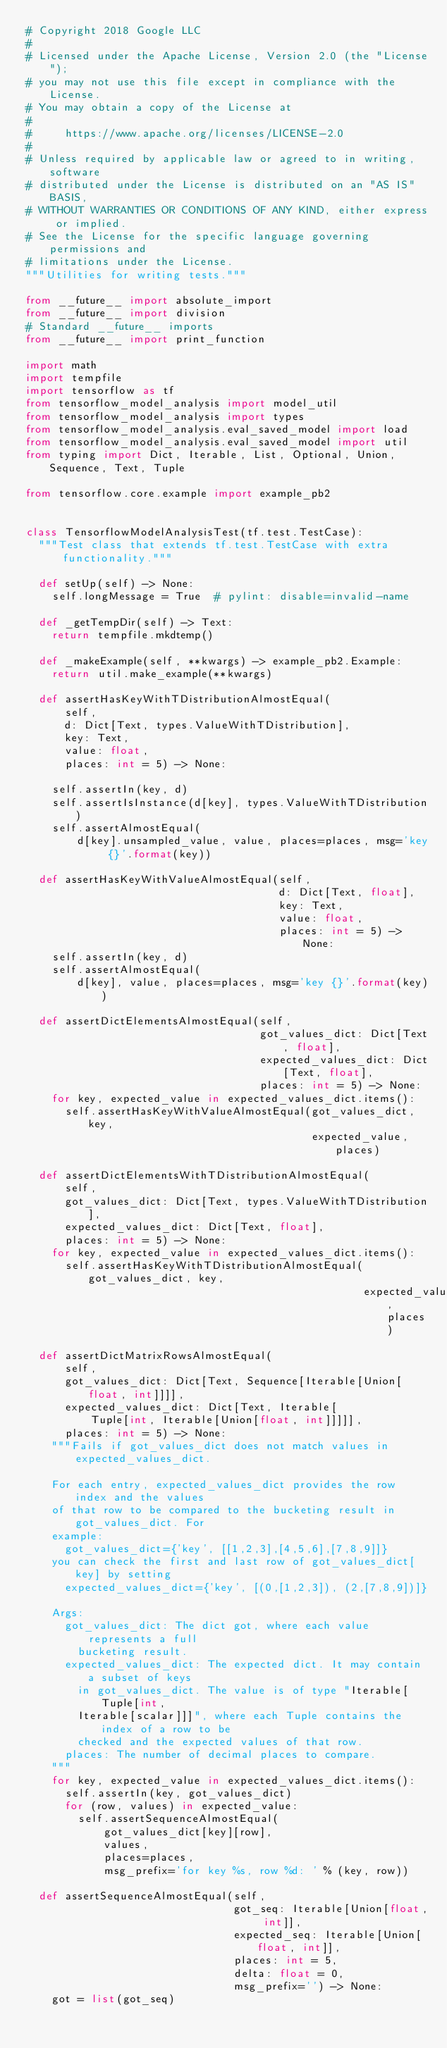Convert code to text. <code><loc_0><loc_0><loc_500><loc_500><_Python_># Copyright 2018 Google LLC
#
# Licensed under the Apache License, Version 2.0 (the "License");
# you may not use this file except in compliance with the License.
# You may obtain a copy of the License at
#
#     https://www.apache.org/licenses/LICENSE-2.0
#
# Unless required by applicable law or agreed to in writing, software
# distributed under the License is distributed on an "AS IS" BASIS,
# WITHOUT WARRANTIES OR CONDITIONS OF ANY KIND, either express or implied.
# See the License for the specific language governing permissions and
# limitations under the License.
"""Utilities for writing tests."""

from __future__ import absolute_import
from __future__ import division
# Standard __future__ imports
from __future__ import print_function

import math
import tempfile
import tensorflow as tf
from tensorflow_model_analysis import model_util
from tensorflow_model_analysis import types
from tensorflow_model_analysis.eval_saved_model import load
from tensorflow_model_analysis.eval_saved_model import util
from typing import Dict, Iterable, List, Optional, Union, Sequence, Text, Tuple

from tensorflow.core.example import example_pb2


class TensorflowModelAnalysisTest(tf.test.TestCase):
  """Test class that extends tf.test.TestCase with extra functionality."""

  def setUp(self) -> None:
    self.longMessage = True  # pylint: disable=invalid-name

  def _getTempDir(self) -> Text:
    return tempfile.mkdtemp()

  def _makeExample(self, **kwargs) -> example_pb2.Example:
    return util.make_example(**kwargs)

  def assertHasKeyWithTDistributionAlmostEqual(
      self,
      d: Dict[Text, types.ValueWithTDistribution],
      key: Text,
      value: float,
      places: int = 5) -> None:

    self.assertIn(key, d)
    self.assertIsInstance(d[key], types.ValueWithTDistribution)
    self.assertAlmostEqual(
        d[key].unsampled_value, value, places=places, msg='key {}'.format(key))

  def assertHasKeyWithValueAlmostEqual(self,
                                       d: Dict[Text, float],
                                       key: Text,
                                       value: float,
                                       places: int = 5) -> None:
    self.assertIn(key, d)
    self.assertAlmostEqual(
        d[key], value, places=places, msg='key {}'.format(key))

  def assertDictElementsAlmostEqual(self,
                                    got_values_dict: Dict[Text, float],
                                    expected_values_dict: Dict[Text, float],
                                    places: int = 5) -> None:
    for key, expected_value in expected_values_dict.items():
      self.assertHasKeyWithValueAlmostEqual(got_values_dict, key,
                                            expected_value, places)

  def assertDictElementsWithTDistributionAlmostEqual(
      self,
      got_values_dict: Dict[Text, types.ValueWithTDistribution],
      expected_values_dict: Dict[Text, float],
      places: int = 5) -> None:
    for key, expected_value in expected_values_dict.items():
      self.assertHasKeyWithTDistributionAlmostEqual(got_values_dict, key,
                                                    expected_value, places)

  def assertDictMatrixRowsAlmostEqual(
      self,
      got_values_dict: Dict[Text, Sequence[Iterable[Union[float, int]]]],
      expected_values_dict: Dict[Text, Iterable[
          Tuple[int, Iterable[Union[float, int]]]]],
      places: int = 5) -> None:
    """Fails if got_values_dict does not match values in expected_values_dict.

    For each entry, expected_values_dict provides the row index and the values
    of that row to be compared to the bucketing result in got_values_dict. For
    example:
      got_values_dict={'key', [[1,2,3],[4,5,6],[7,8,9]]}
    you can check the first and last row of got_values_dict[key] by setting
      expected_values_dict={'key', [(0,[1,2,3]), (2,[7,8,9])]}

    Args:
      got_values_dict: The dict got, where each value represents a full
        bucketing result.
      expected_values_dict: The expected dict. It may contain a subset of keys
        in got_values_dict. The value is of type "Iterable[Tuple[int,
        Iterable[scalar]]]", where each Tuple contains the index of a row to be
        checked and the expected values of that row.
      places: The number of decimal places to compare.
    """
    for key, expected_value in expected_values_dict.items():
      self.assertIn(key, got_values_dict)
      for (row, values) in expected_value:
        self.assertSequenceAlmostEqual(
            got_values_dict[key][row],
            values,
            places=places,
            msg_prefix='for key %s, row %d: ' % (key, row))

  def assertSequenceAlmostEqual(self,
                                got_seq: Iterable[Union[float, int]],
                                expected_seq: Iterable[Union[float, int]],
                                places: int = 5,
                                delta: float = 0,
                                msg_prefix='') -> None:
    got = list(got_seq)</code> 